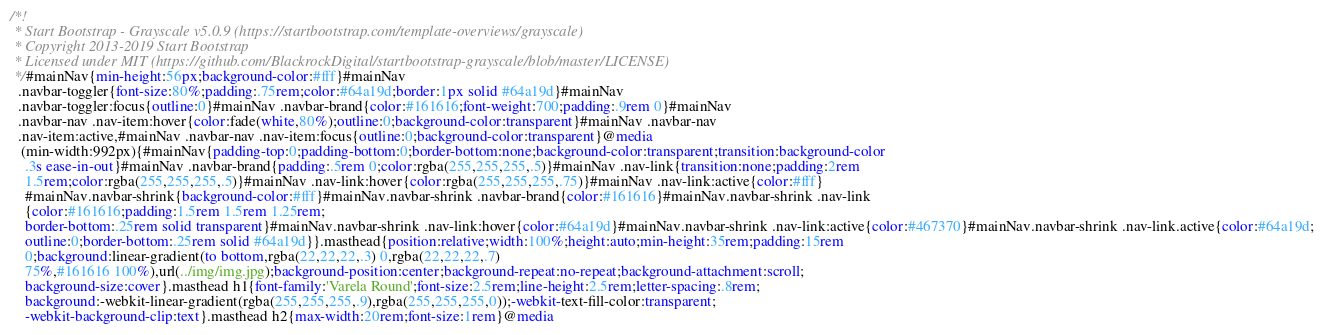<code> <loc_0><loc_0><loc_500><loc_500><_CSS_>/*!
 * Start Bootstrap - Grayscale v5.0.9 (https://startbootstrap.com/template-overviews/grayscale)
 * Copyright 2013-2019 Start Bootstrap
 * Licensed under MIT (https://github.com/BlackrockDigital/startbootstrap-grayscale/blob/master/LICENSE)
 */#mainNav{min-height:56px;background-color:#fff}#mainNav
  .navbar-toggler{font-size:80%;padding:.75rem;color:#64a19d;border:1px solid #64a19d}#mainNav 
  .navbar-toggler:focus{outline:0}#mainNav .navbar-brand{color:#161616;font-weight:700;padding:.9rem 0}#mainNav 
  .navbar-nav .nav-item:hover{color:fade(white,80%);outline:0;background-color:transparent}#mainNav .navbar-nav 
  .nav-item:active,#mainNav .navbar-nav .nav-item:focus{outline:0;background-color:transparent}@media
   (min-width:992px){#mainNav{padding-top:0;padding-bottom:0;border-bottom:none;background-color:transparent;transition:background-color 
    .3s ease-in-out}#mainNav .navbar-brand{padding:.5rem 0;color:rgba(255,255,255,.5)}#mainNav .nav-link{transition:none;padding:2rem 
    1.5rem;color:rgba(255,255,255,.5)}#mainNav .nav-link:hover{color:rgba(255,255,255,.75)}#mainNav .nav-link:active{color:#fff}
    #mainNav.navbar-shrink{background-color:#fff}#mainNav.navbar-shrink .navbar-brand{color:#161616}#mainNav.navbar-shrink .nav-link
    {color:#161616;padding:1.5rem 1.5rem 1.25rem;
    border-bottom:.25rem solid transparent}#mainNav.navbar-shrink .nav-link:hover{color:#64a19d}#mainNav.navbar-shrink .nav-link:active{color:#467370}#mainNav.navbar-shrink .nav-link.active{color:#64a19d;
    outline:0;border-bottom:.25rem solid #64a19d}}.masthead{position:relative;width:100%;height:auto;min-height:35rem;padding:15rem 
    0;background:linear-gradient(to bottom,rgba(22,22,22,.3) 0,rgba(22,22,22,.7) 
    75%,#161616 100%),url(../img/img.jpg);background-position:center;background-repeat:no-repeat;background-attachment:scroll;
    background-size:cover}.masthead h1{font-family:'Varela Round';font-size:2.5rem;line-height:2.5rem;letter-spacing:.8rem;
    background:-webkit-linear-gradient(rgba(255,255,255,.9),rgba(255,255,255,0));-webkit-text-fill-color:transparent;
    -webkit-background-clip:text}.masthead h2{max-width:20rem;font-size:1rem}@media</code> 